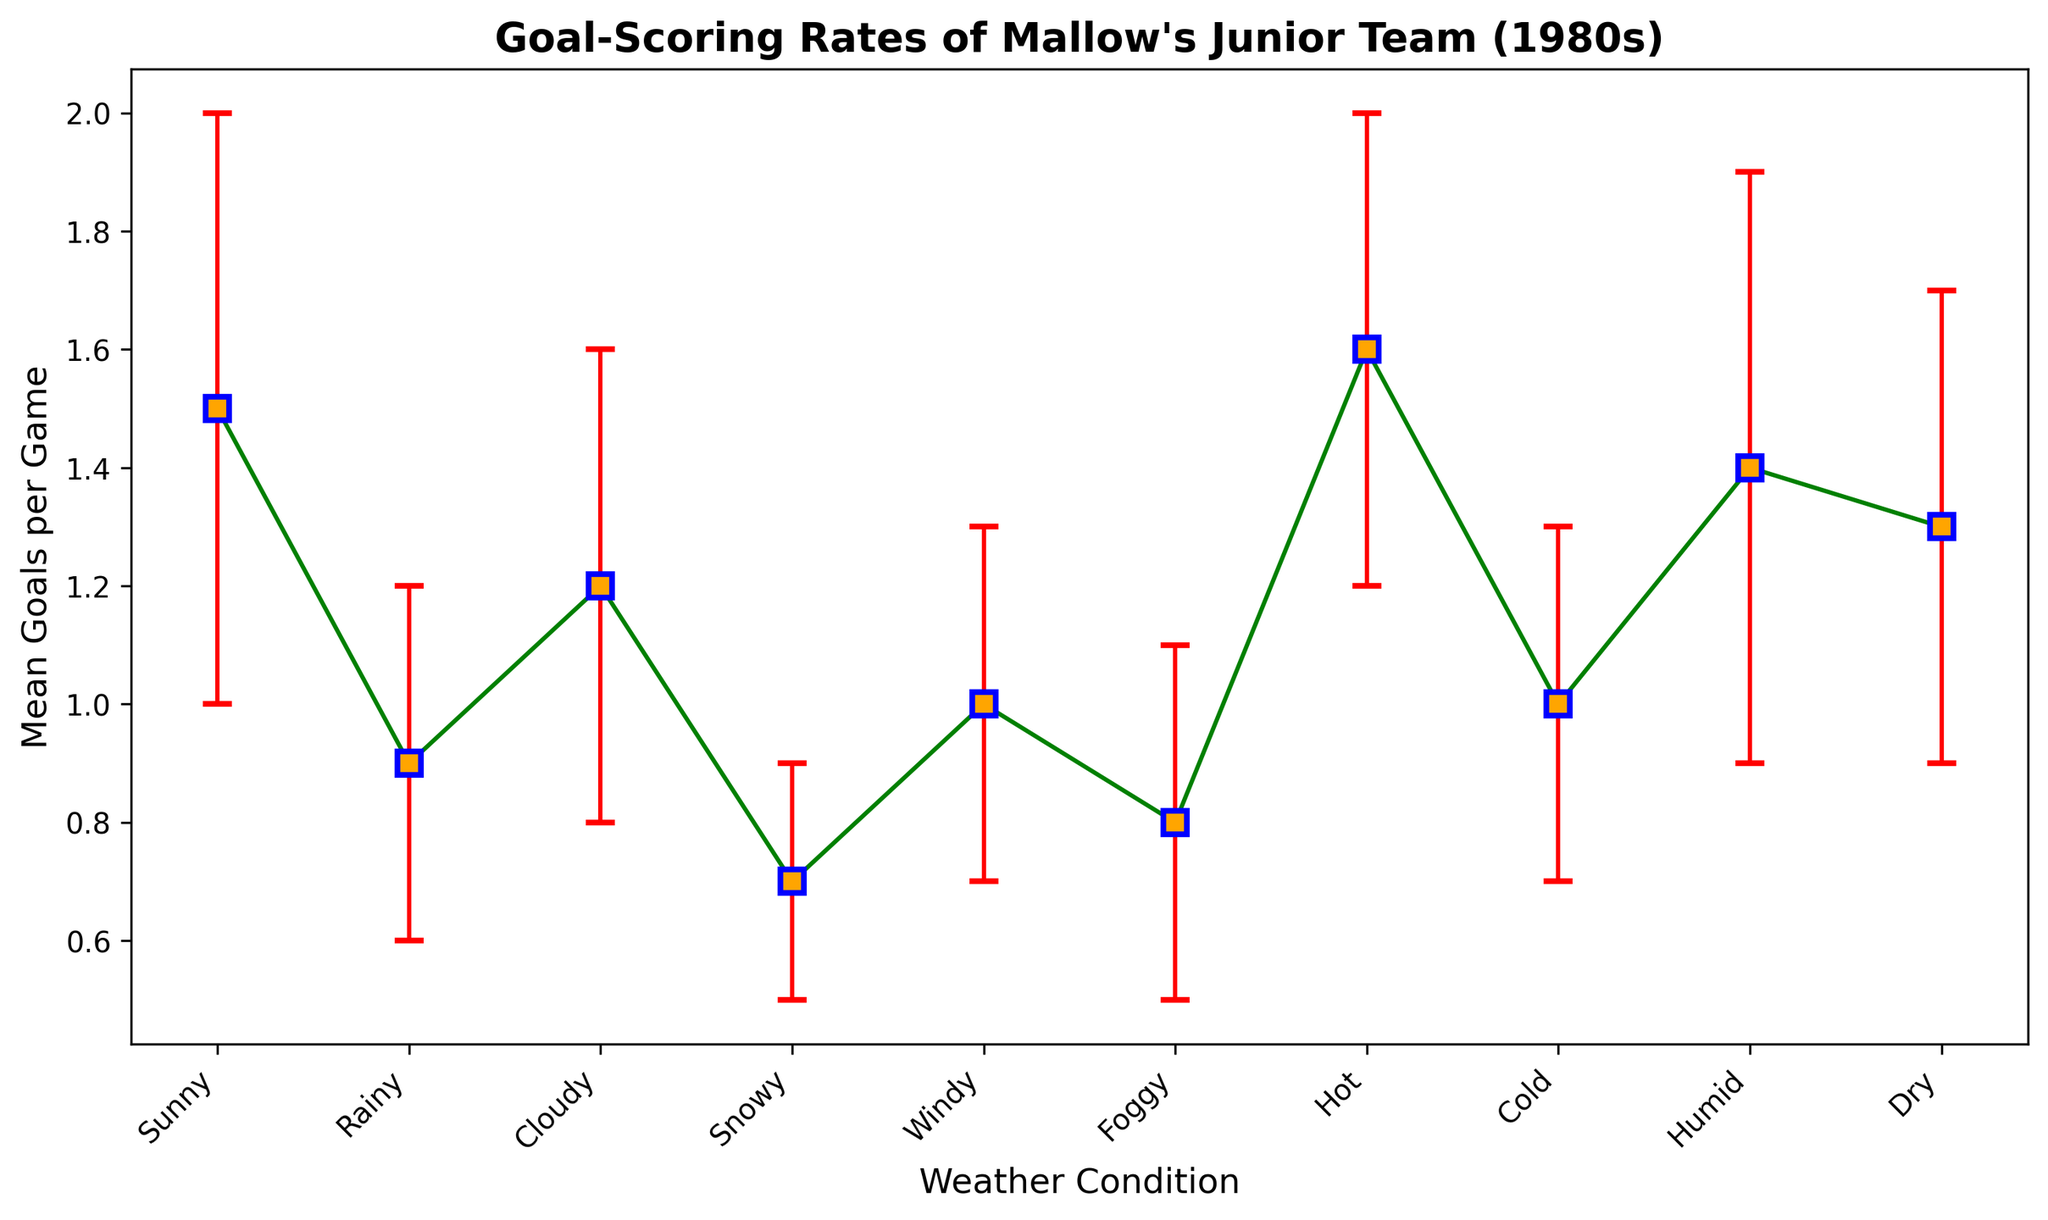What's the weather condition with the highest mean goals per game? Identify the highest point on the y-axis representing the mean goals per game. From the chart, the hot condition has the highest mean goals per game at 1.6.
Answer: Hot Which weather condition has the lowest mean goals per game? Locate the lowest point on the y-axis representing the mean goals per game. Snowy weather has the lowest mean goals per game at 0.7.
Answer: Snowy How does the goal-scoring rate on sunny days compare with rainy days? Compare the heights of the points for sunny and rainy conditions. Sunny days have a higher mean goal-scoring rate (1.5) compared to rainy days (0.9).
Answer: Sunny days have a higher rate What's the average goal-scoring rate across all weather conditions? Add all the mean goals per game and divide by the number of weather conditions:
(1.5 + 0.9 + 1.2 + 0.7 + 1.0 + 0.8 + 1.6 + 1.0 + 1.4 + 1.3) / 10 = 11.4 / 10 = 1.14
Answer: 1.14 What is the difference between the goal-scoring rate in hot and cold weather? Subtract the mean goals per game in cold weather from the mean goals per game in hot weather:
1.6 - 1.0 = 0.6
Answer: 0.6 Which weather conditions have a mean goals per game higher than 1.3? Identify points above the 1.3 mark on the y-axis. Hot, Humid, and Dry weather conditions have mean goals per game higher than 1.3.
Answer: Hot, Humid, Dry What weather condition has the most uncertainty in goal-scoring rates, based on the error bars? Look for the longest error bar. Sunny weather has the largest error bar, indicating the most uncertainty.
Answer: Sunny How does the goal-scoring rate in dry weather compare to cloudy weather? Compare the points for dry and cloudy weather. Dry weather has a mean goal-scoring rate of 1.3, which is higher than cloudy weather at 1.2.
Answer: Dry has a higher rate Rank the weather conditions from highest to lowest mean goal-scoring rate. Order the conditions by their mean goal values:
1. Hot (1.6)
2. Sunny (1.5)
3. Humid (1.4)
4. Dry (1.3)
5. Cloudy (1.2)
6. Windy (1.0)
7. Cold (1.0)
8. Rainy (0.9)
9. Foggy (0.8)
10. Snowy (0.7)
Answer: Hot, Sunny, Humid, Dry, Cloudy, Windy, Cold, Rainy, Foggy, Snowy In which weather conditions can we expect a mean goal-scoring rate around 1.0? Look for mean goal values close to 1.0. Windy, Cold, and Rainy weather conditions have mean goals per game near 1.0.
Answer: Windy, Cold, Rainy 